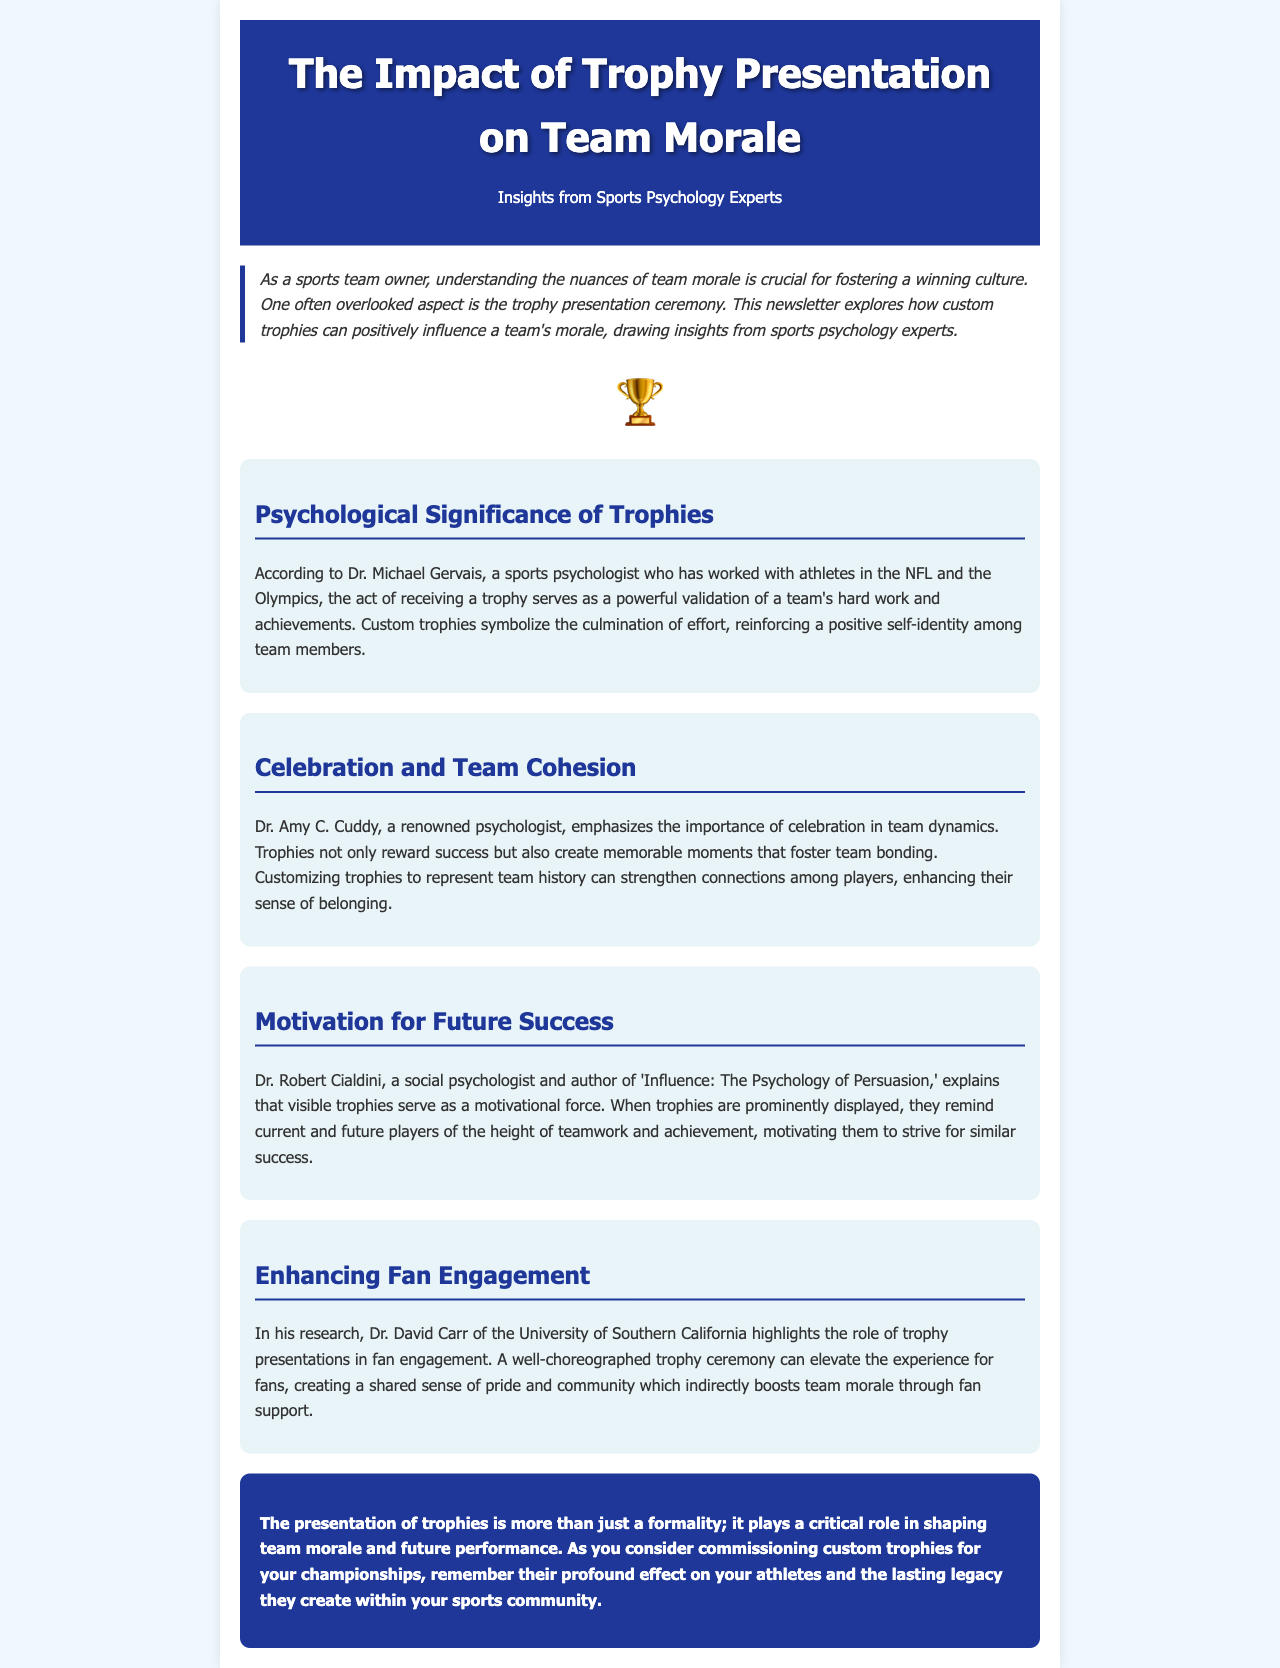What is the title of the newsletter? The title of the newsletter is prominently displayed in the header section and reads "The Impact of Trophy Presentation on Team Morale."
Answer: The Impact of Trophy Presentation on Team Morale Who is the sports psychologist that discusses the psychological significance of trophies? Dr. Michael Gervais is mentioned as the sports psychologist discussing the significance of trophies in the document.
Answer: Dr. Michael Gervais What is the main theme of the key insights provided in the newsletter? Each key insight discusses different aspects of how trophy presentation impacts team morale, including psychological significance, celebration, motivation, and fan engagement.
Answer: Impact on team morale Who emphasizes the importance of celebration in team dynamics? The document cites Dr. Amy C. Cuddy as the psychologist emphasizing celebration in team dynamics.
Answer: Dr. Amy C. Cuddy Which psychologist explains the motivational force of visible trophies? Dr. Robert Cialdini is the psychologist who explains the motivational force of visible trophies.
Answer: Dr. Robert Cialdini What does Dr. David Carr highlight regarding trophy presentations? Dr. David Carr highlights the role of trophy presentations in enhancing fan engagement and community pride.
Answer: Fan engagement What color is used for the header background? The header background of the newsletter features a deep blue color, specifically represented by the hex code #1e3799.
Answer: #1e3799 What emotional effect do customized trophies have on team members? The customization of trophies symbolizes effort and reinforces a positive self-identity among team members.
Answer: Positive self-identity 